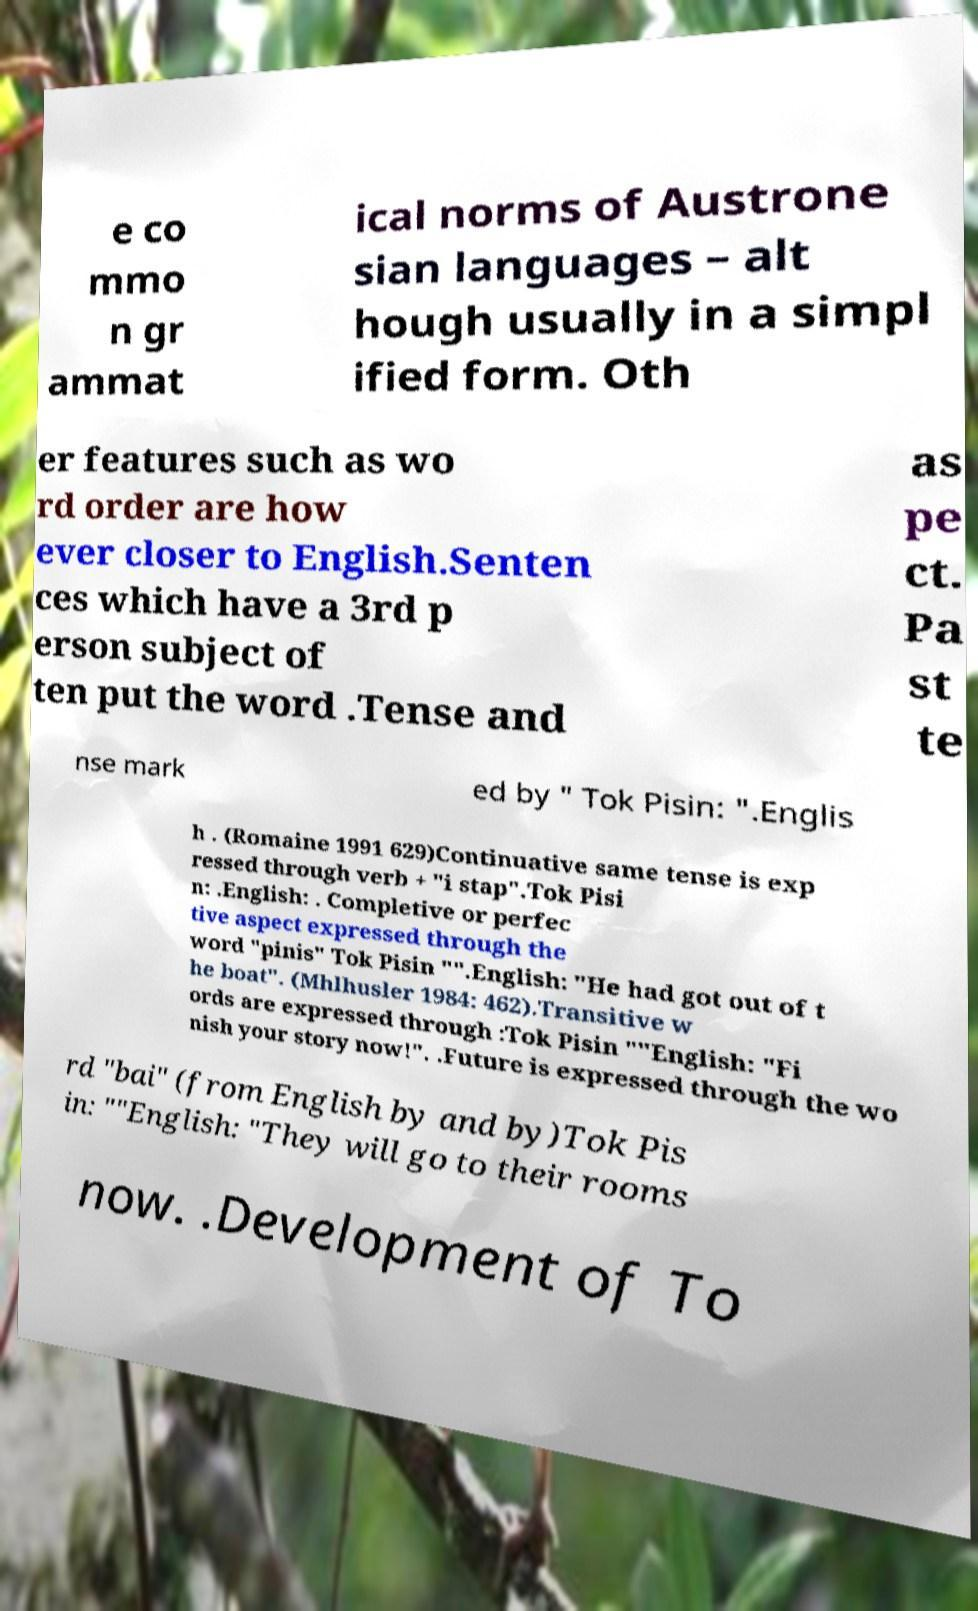Can you read and provide the text displayed in the image?This photo seems to have some interesting text. Can you extract and type it out for me? e co mmo n gr ammat ical norms of Austrone sian languages – alt hough usually in a simpl ified form. Oth er features such as wo rd order are how ever closer to English.Senten ces which have a 3rd p erson subject of ten put the word .Tense and as pe ct. Pa st te nse mark ed by " Tok Pisin: ".Englis h . (Romaine 1991 629)Continuative same tense is exp ressed through verb + "i stap".Tok Pisi n: .English: . Completive or perfec tive aspect expressed through the word "pinis" Tok Pisin "".English: "He had got out of t he boat". (Mhlhusler 1984: 462).Transitive w ords are expressed through :Tok Pisin ""English: "Fi nish your story now!". .Future is expressed through the wo rd "bai" (from English by and by)Tok Pis in: ""English: "They will go to their rooms now. .Development of To 